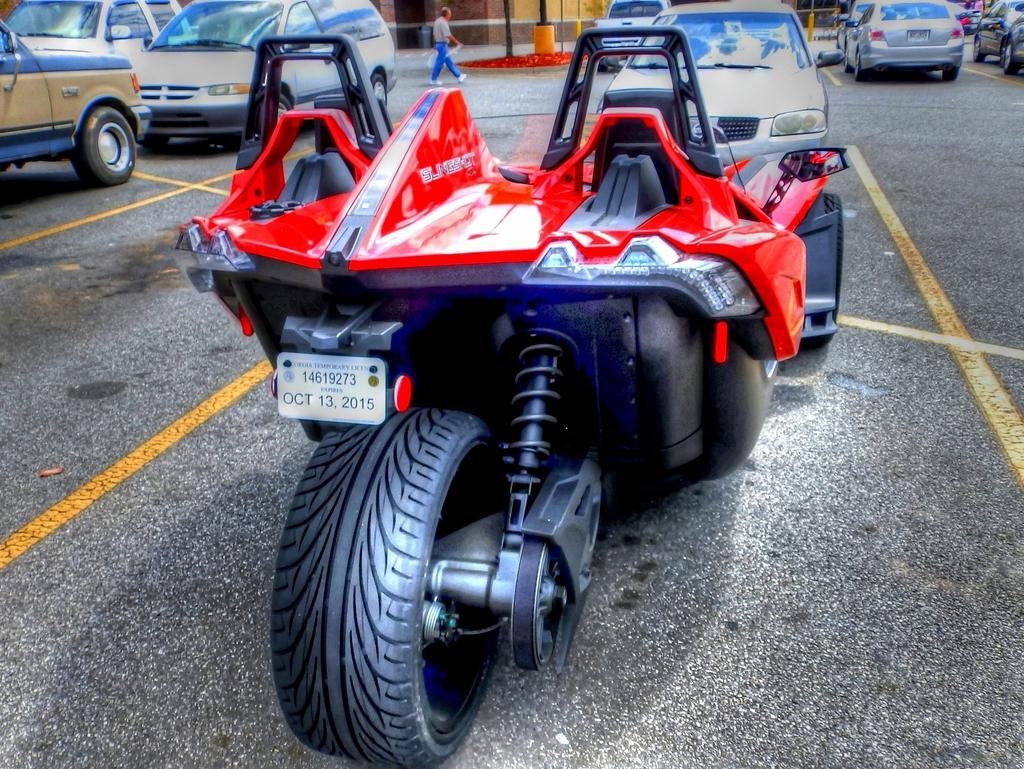What can be seen on the road in the image? There are many vehicles on the road in the image. What is the person in the image doing? The person is walking in the image. What is the person wearing? The person is wearing clothes. Can you identify any specific details about the vehicles in the image? The number plate of a vehicle is visible in the image. Can you see any horses or toads in the image? No, there are no horses or toads present in the image. What type of stocking is the person wearing in the image? The person is not wearing stockings in the image; they are wearing clothes. 